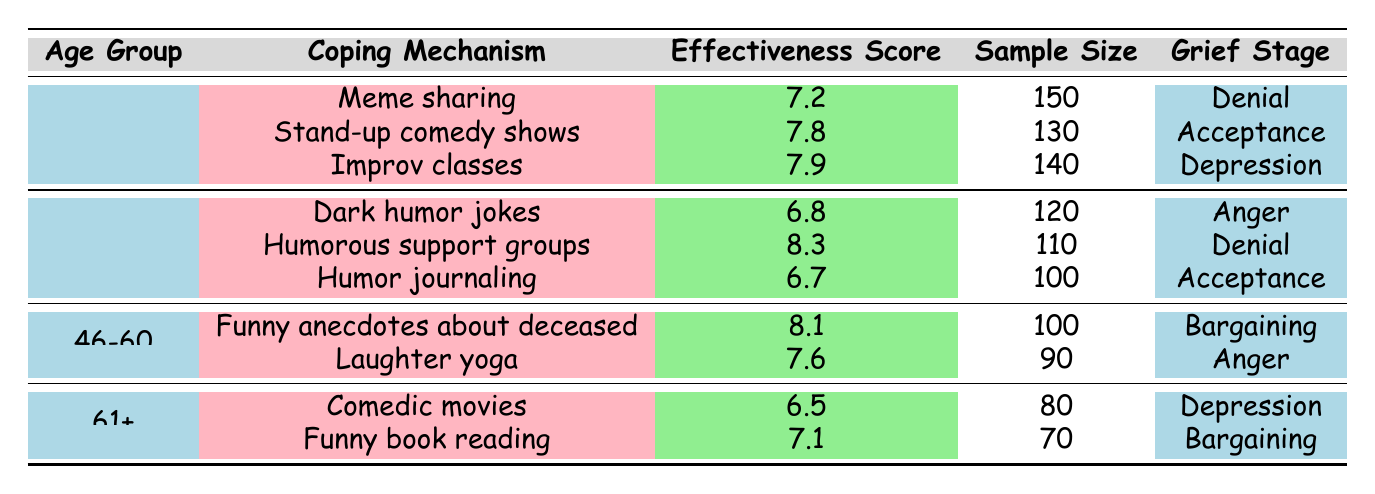What is the effectiveness score of "Funny anecdotes about deceased"? Referring to the table, the effectiveness score for "Funny anecdotes about deceased" is listed under the "46-60" age group. The value in the effectiveness score column for this mechanism is 8.1.
Answer: 8.1 Which coping mechanism has the highest effectiveness score in the 31-45 age group? In the "31-45" age group, there are three coping mechanisms: "Dark humor jokes" with a score of 6.8, "Humorous support groups" with a score of 8.3, and "Humor journaling" with a score of 6.7. The highest score among these is 8.3 for "Humorous support groups."
Answer: Humorous support groups What is the average effectiveness score of coping mechanisms for the age group 61+? The coping mechanisms for the 61+ age group are "Comedic movies" (6.5) and "Funny book reading" (7.1). To find the average, we add these scores: 6.5 + 7.1 = 13.6, then divide by 2 to get the average: 13.6 / 2 = 6.8.
Answer: 6.8 Are there any coping mechanisms in the 18-30 age group with an effectiveness score greater than 7.5? In the "18-30" age group, the coping mechanisms are "Meme sharing" (7.2), "Stand-up comedy shows" (7.8), and "Improv classes" (7.9). Both "Stand-up comedy shows" and "Improv classes" have scores greater than 7.5. Therefore, the answer is yes.
Answer: Yes Which gender reported the highest effectiveness score in the 31-45 age group? In the "31-45" age group, there are two mechanisms listed by gender: "Dark humor jokes" (Male, 6.8) and "Humorous support groups" (Female, 8.3), and "Humor journaling" (Male, 6.7). "Humorous support groups" has the highest score of 8.3, reported by a female.
Answer: Female 